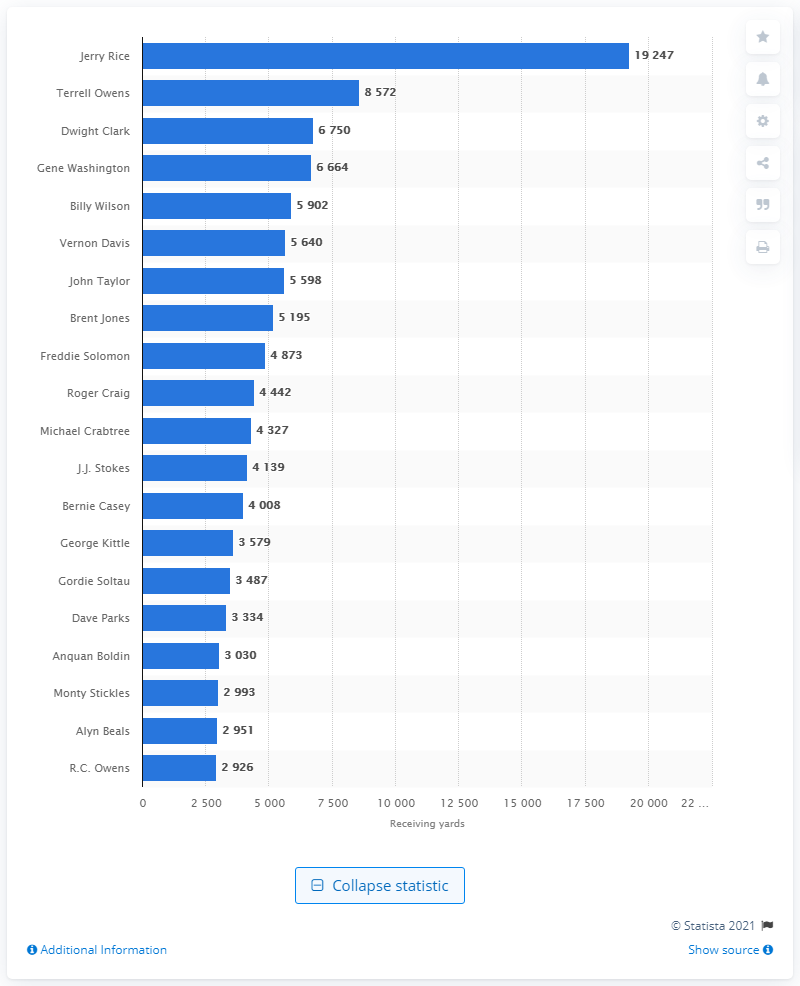Draw attention to some important aspects in this diagram. Jerry Rice is the career receiving leader of the San Francisco 49ers. 